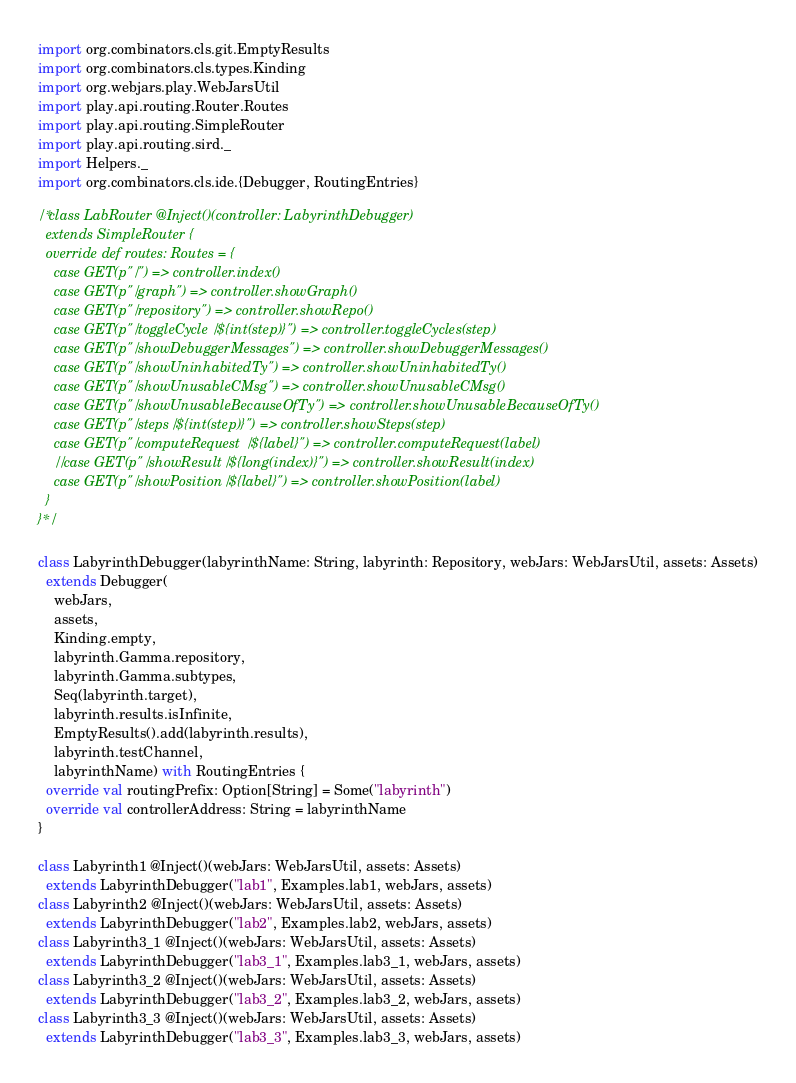Convert code to text. <code><loc_0><loc_0><loc_500><loc_500><_Scala_>import org.combinators.cls.git.EmptyResults
import org.combinators.cls.types.Kinding
import org.webjars.play.WebJarsUtil
import play.api.routing.Router.Routes
import play.api.routing.SimpleRouter
import play.api.routing.sird._
import Helpers._
import org.combinators.cls.ide.{Debugger, RoutingEntries}

/*class LabRouter @Inject()(controller: LabyrinthDebugger)
  extends SimpleRouter {
  override def routes: Routes = {
    case GET(p"/") => controller.index()
    case GET(p"/graph") => controller.showGraph()
    case GET(p"/repository") => controller.showRepo()
    case GET(p"/toggleCycle/${int(step)}") => controller.toggleCycles(step)
    case GET(p"/showDebuggerMessages") => controller.showDebuggerMessages()
    case GET(p"/showUninhabitedTy") => controller.showUninhabitedTy()
    case GET(p"/showUnusableCMsg") => controller.showUnusableCMsg()
    case GET(p"/showUnusableBecauseOfTy") => controller.showUnusableBecauseOfTy()
    case GET(p"/steps/${int(step)}") => controller.showSteps(step)
    case GET(p"/computeRequest/${label}") => controller.computeRequest(label)
    //case GET(p"/showResult/${long(index)}") => controller.showResult(index)
    case GET(p"/showPosition/${label}") => controller.showPosition(label)
  }
}*/

class LabyrinthDebugger(labyrinthName: String, labyrinth: Repository, webJars: WebJarsUtil, assets: Assets)
  extends Debugger(
    webJars,
    assets,
    Kinding.empty,
    labyrinth.Gamma.repository,
    labyrinth.Gamma.subtypes,
    Seq(labyrinth.target),
    labyrinth.results.isInfinite,
    EmptyResults().add(labyrinth.results),
    labyrinth.testChannel,
    labyrinthName) with RoutingEntries {
  override val routingPrefix: Option[String] = Some("labyrinth")
  override val controllerAddress: String = labyrinthName
}

class Labyrinth1 @Inject()(webJars: WebJarsUtil, assets: Assets)
  extends LabyrinthDebugger("lab1", Examples.lab1, webJars, assets)
class Labyrinth2 @Inject()(webJars: WebJarsUtil, assets: Assets)
  extends LabyrinthDebugger("lab2", Examples.lab2, webJars, assets)
class Labyrinth3_1 @Inject()(webJars: WebJarsUtil, assets: Assets)
  extends LabyrinthDebugger("lab3_1", Examples.lab3_1, webJars, assets)
class Labyrinth3_2 @Inject()(webJars: WebJarsUtil, assets: Assets)
  extends LabyrinthDebugger("lab3_2", Examples.lab3_2, webJars, assets)
class Labyrinth3_3 @Inject()(webJars: WebJarsUtil, assets: Assets)
  extends LabyrinthDebugger("lab3_3", Examples.lab3_3, webJars, assets)


</code> 